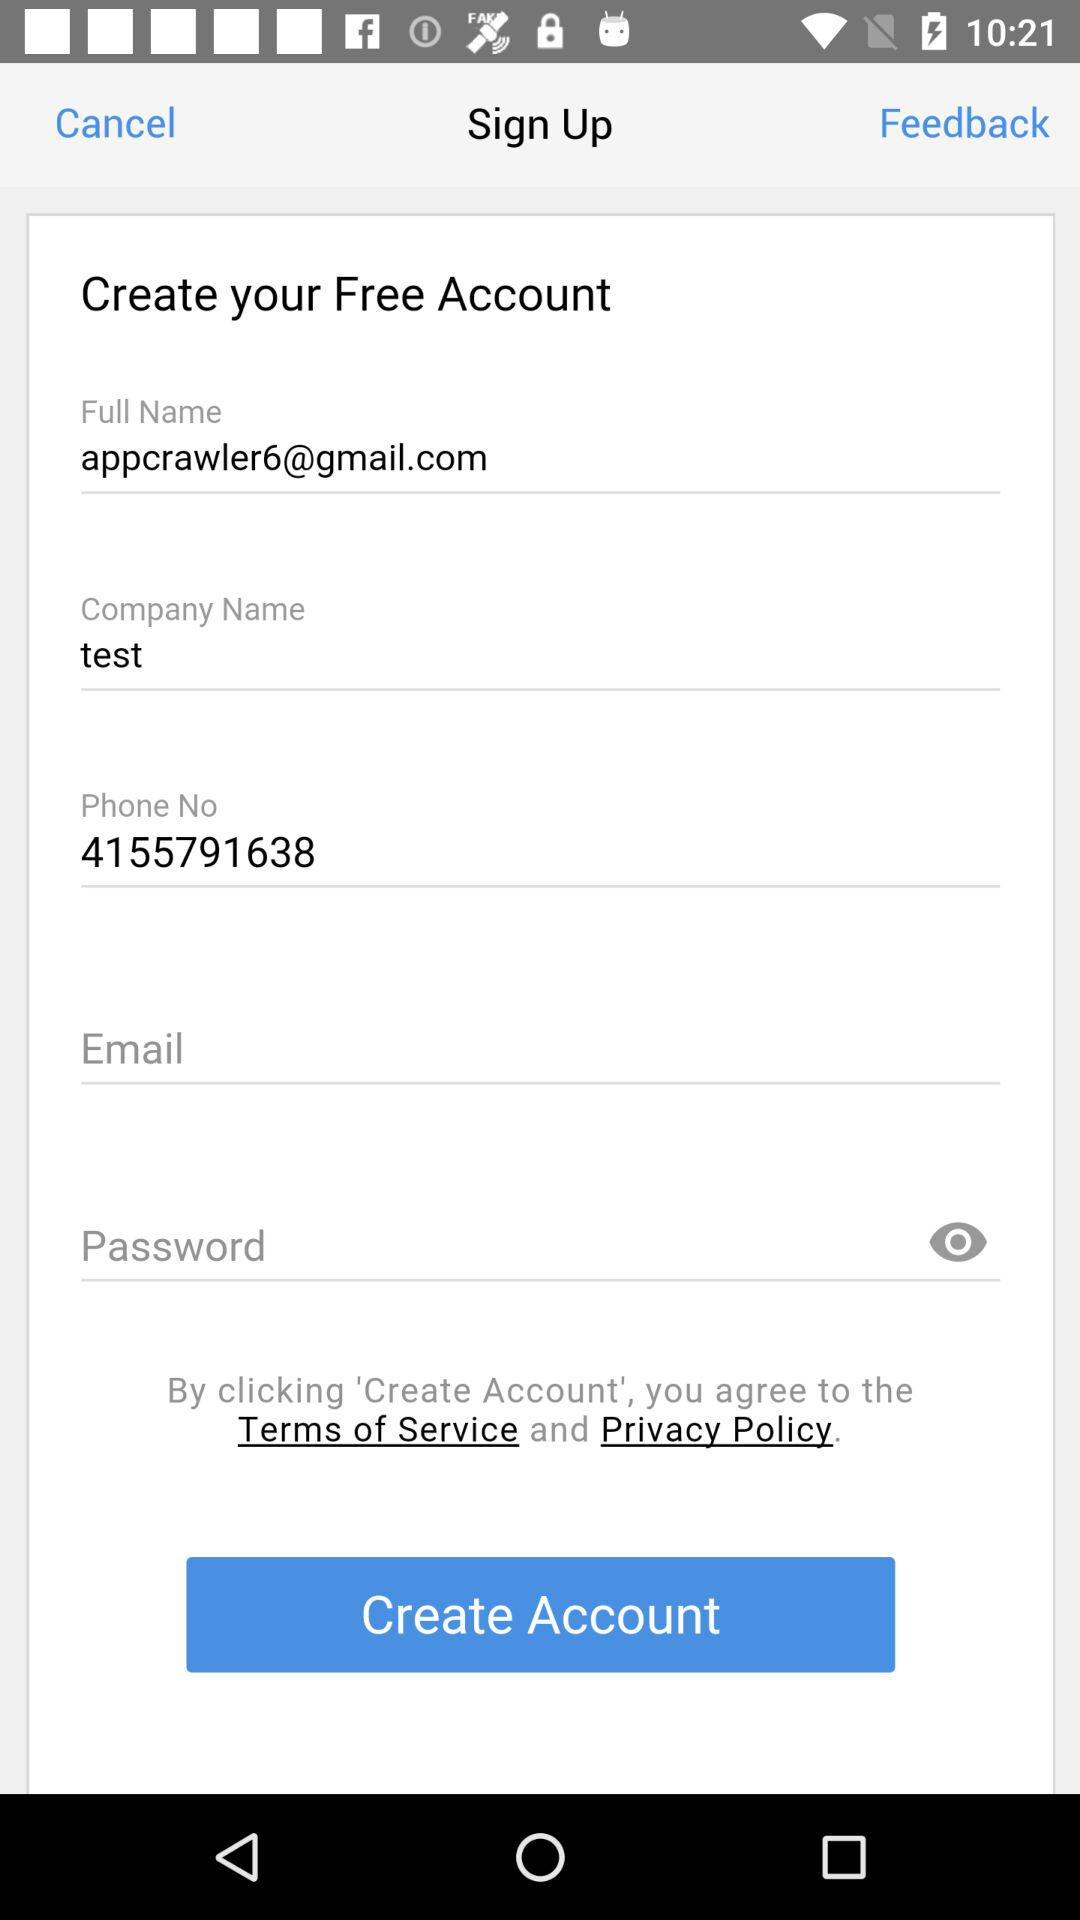What is written in the full name? The text written in the full name is appcrawler6@gmail.com. 